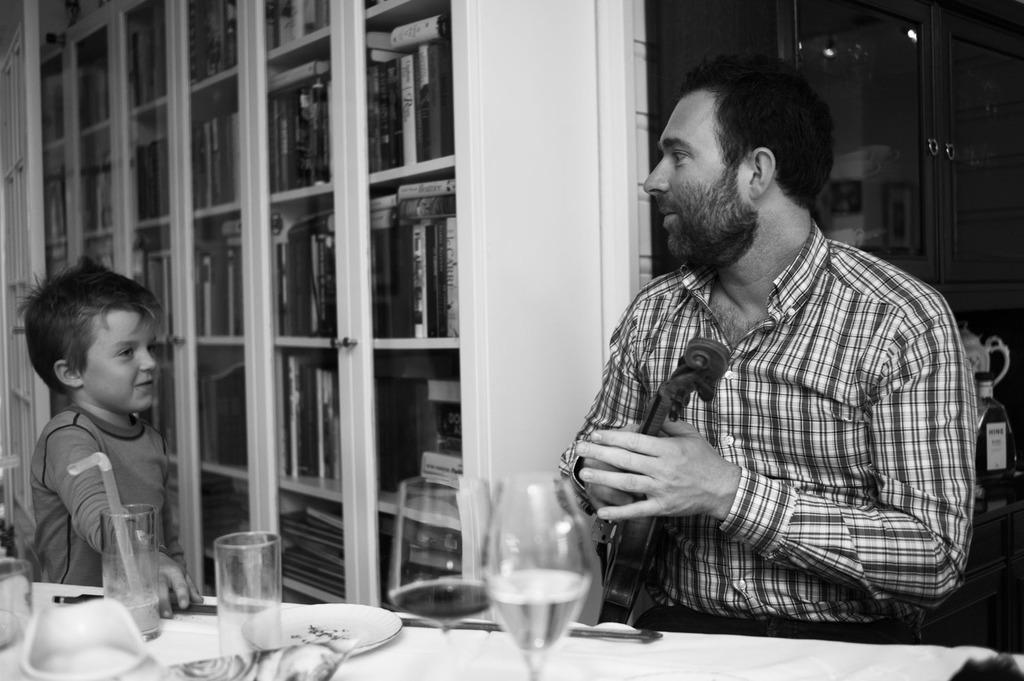Can you describe this image briefly? A person is holding a violin and sitting. And another baby is standing near to the left side. In front of him there is a table. On the table there are glasses, plates. In the background there is a wall with a cupboard. Inside the cupboard there are many books. Also there is a bottle in the right side. 